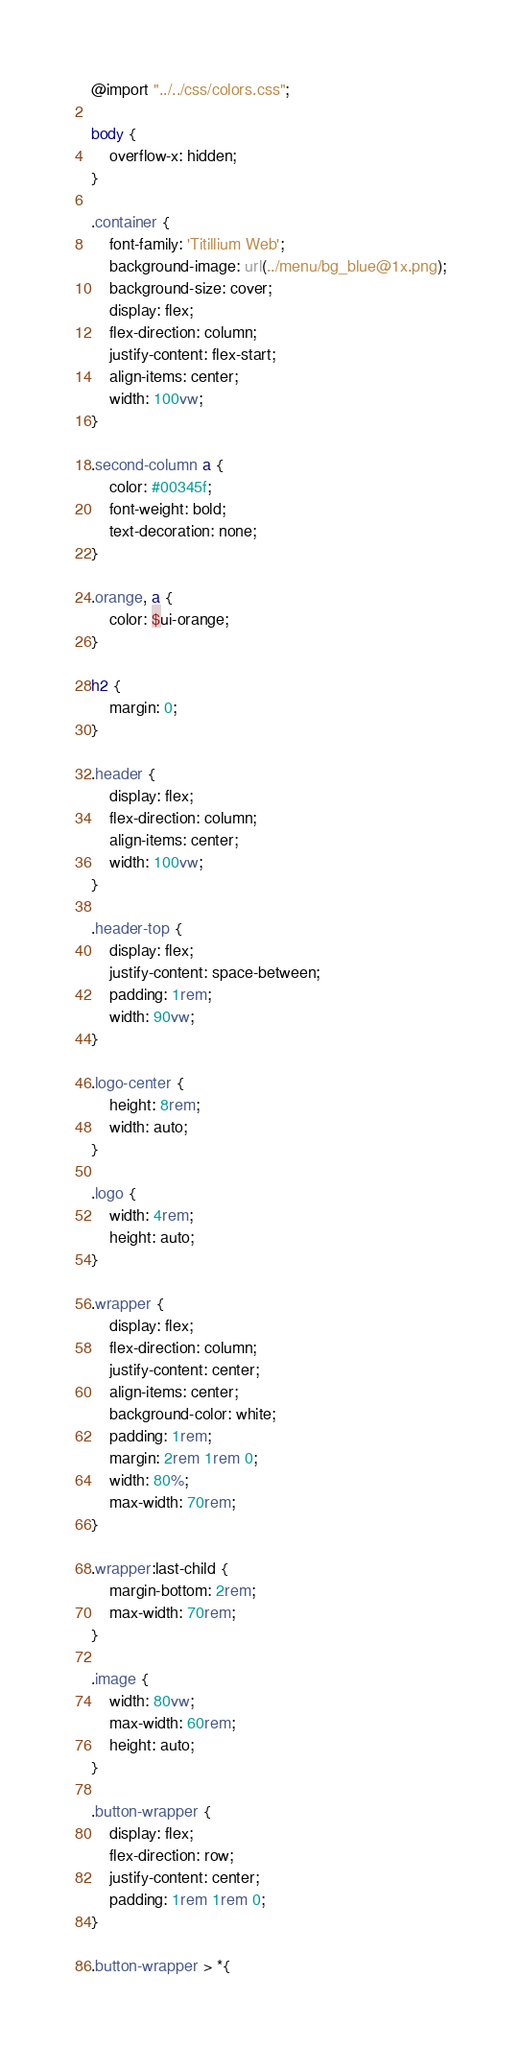Convert code to text. <code><loc_0><loc_0><loc_500><loc_500><_CSS_>@import "../../css/colors.css";

body {
    overflow-x: hidden;
}

.container {
    font-family: 'Titillium Web';
    background-image: url(../menu/bg_blue@1x.png);
    background-size: cover;
    display: flex;
    flex-direction: column;
    justify-content: flex-start;
    align-items: center;
    width: 100vw;
}

.second-column a {
    color: #00345f;
    font-weight: bold;
    text-decoration: none;
}

.orange, a {
    color: $ui-orange;
}

h2 {
    margin: 0;
}

.header {
    display: flex;
    flex-direction: column;
    align-items: center;
    width: 100vw;
}

.header-top {
    display: flex;
    justify-content: space-between;
    padding: 1rem;
    width: 90vw;
}

.logo-center {
    height: 8rem;
    width: auto;
}

.logo {
    width: 4rem;
    height: auto;
}

.wrapper {
    display: flex;
    flex-direction: column;
    justify-content: center;
    align-items: center;
    background-color: white;
    padding: 1rem;
    margin: 2rem 1rem 0;
    width: 80%;
    max-width: 70rem;
}

.wrapper:last-child {
    margin-bottom: 2rem;
    max-width: 70rem;
}

.image {
    width: 80vw;
    max-width: 60rem;
    height: auto;
}

.button-wrapper {
    display: flex;
    flex-direction: row;
    justify-content: center;
    padding: 1rem 1rem 0;
}

.button-wrapper > *{</code> 